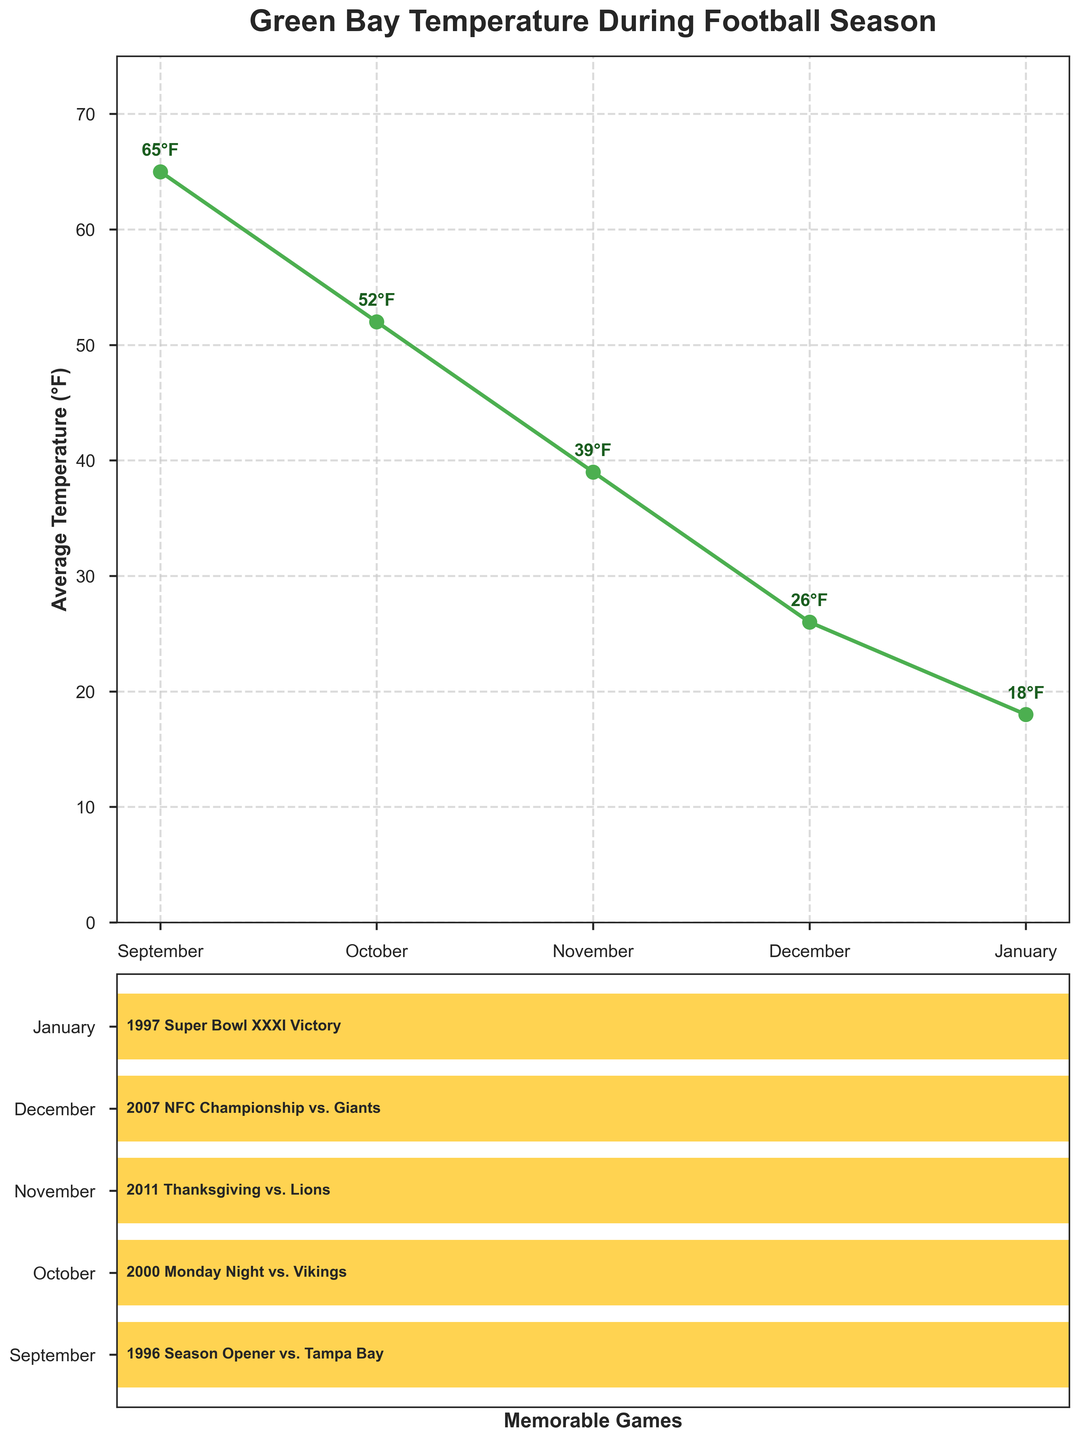What's the title of the figure? The title is displayed at the top of the temperature plot. It reads "Green Bay Temperature During Football Season".
Answer: Green Bay Temperature During Football Season What is the average temperature in December? The data point for December in the temperature plot shows an average temperature, which is annotated next to the data point.
Answer: 26°F Which month has the lowest average temperature? By looking at the temperature plot and comparing the data points, January has the lowest annotated average temperature.
Answer: January What are the average temperatures for October and November? Refer to the temperature plot and read the annotated temperatures for both October and November. October is 52°F, and November is 39°F.
Answer: October: 52°F, November: 39°F Which month had the 1996 Season Opener vs. Tampa Bay as a memorable game? In the bar plot, look for the "1996 Season Opener vs. Tampa Bay" label and match it with the corresponding month on the y-axis.
Answer: September Calculate the difference in average temperature between September and December. The average temperature in September (65°F) minus the average temperature in December (26°F) gives the difference. 65°F - 26°F = 39°F.
Answer: 39°F In which month is there a memorable game with the lowest average temperature recorded? Identify the lowest average temperature in the temperature plot (January at 18°F) and check the corresponding memorable game in January ("1997 Super Bowl XXXI Victory").
Answer: January Which two months have the most significant difference in average temperature? Look at the temperature plot and calculate the differences between each pair of months. The largest difference is between the highest (September) and the lowest (January) temperatures: 65°F - 18°F = 47°F.
Answer: September and January In what month was the NFC Championship vs. Giants and what was the average temperature? Refer to the bar plot for the "2007 NFC Championship vs. Giants" label and find the month (December). Then, check the temperature plot for December's temperature (26°F).
Answer: December, 26°F 